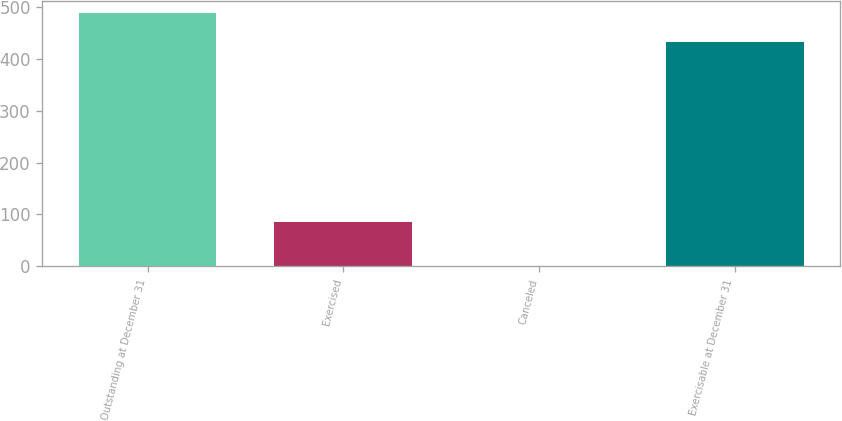Convert chart to OTSL. <chart><loc_0><loc_0><loc_500><loc_500><bar_chart><fcel>Outstanding at December 31<fcel>Exercised<fcel>Canceled<fcel>Exercisable at December 31<nl><fcel>487.8<fcel>85<fcel>1<fcel>433<nl></chart> 